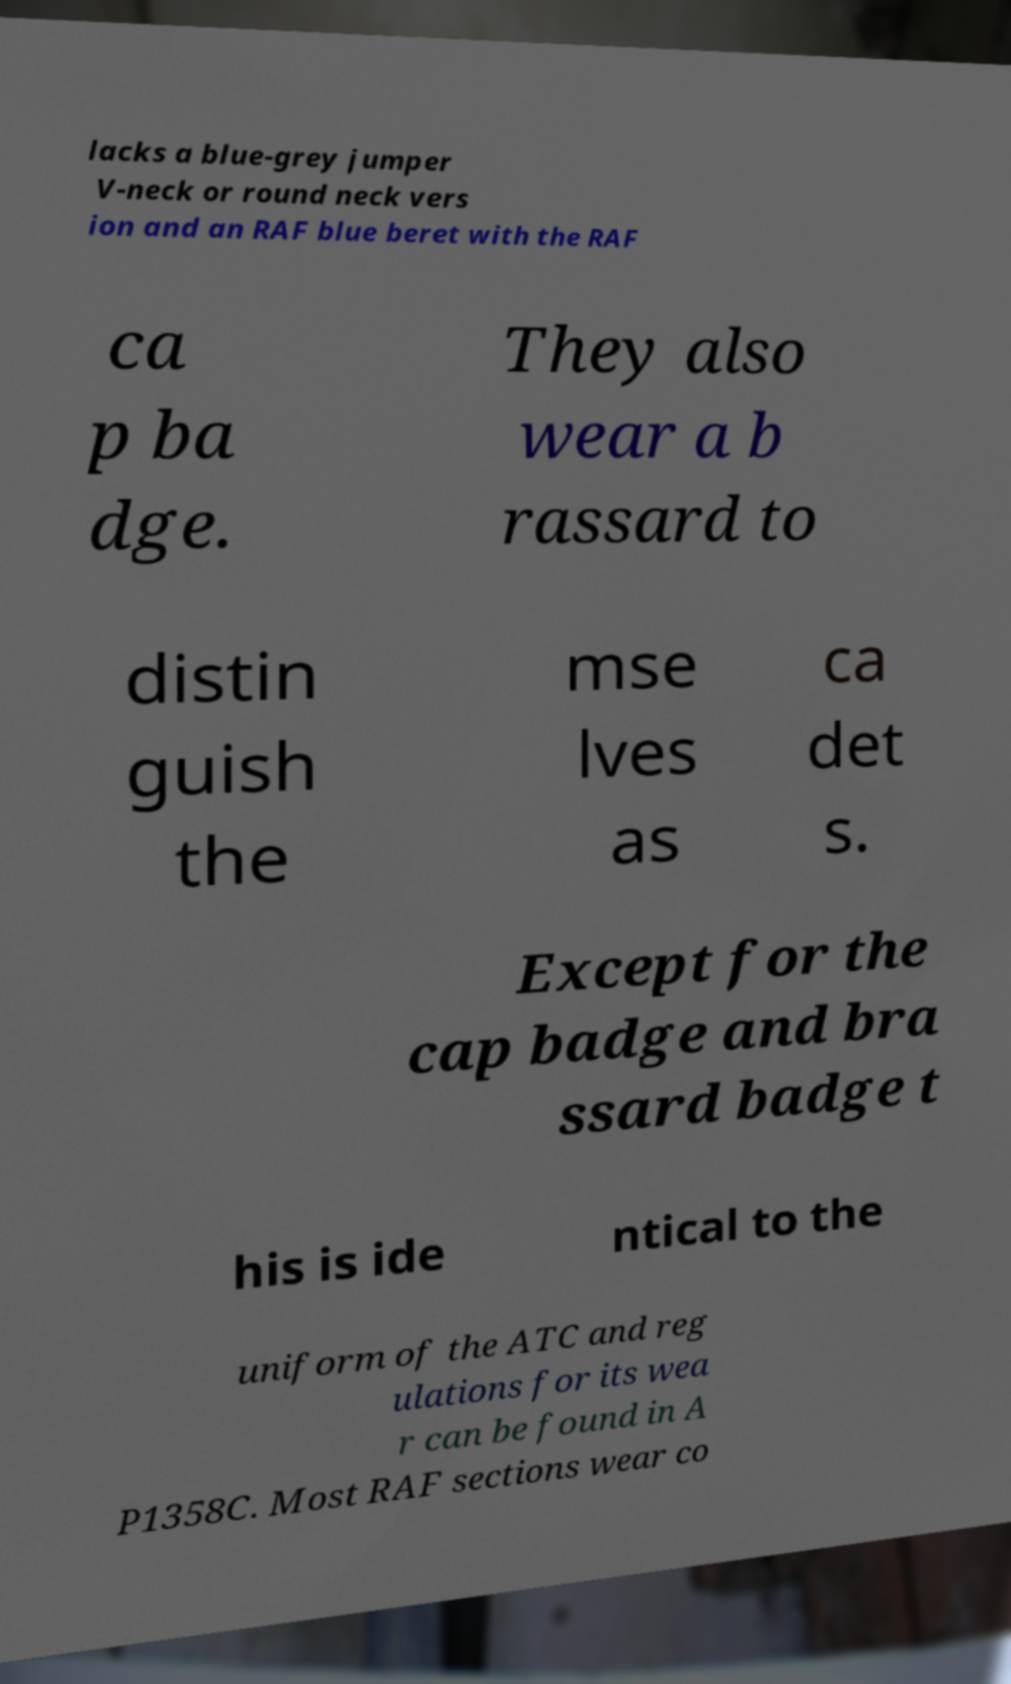There's text embedded in this image that I need extracted. Can you transcribe it verbatim? lacks a blue-grey jumper V-neck or round neck vers ion and an RAF blue beret with the RAF ca p ba dge. They also wear a b rassard to distin guish the mse lves as ca det s. Except for the cap badge and bra ssard badge t his is ide ntical to the uniform of the ATC and reg ulations for its wea r can be found in A P1358C. Most RAF sections wear co 